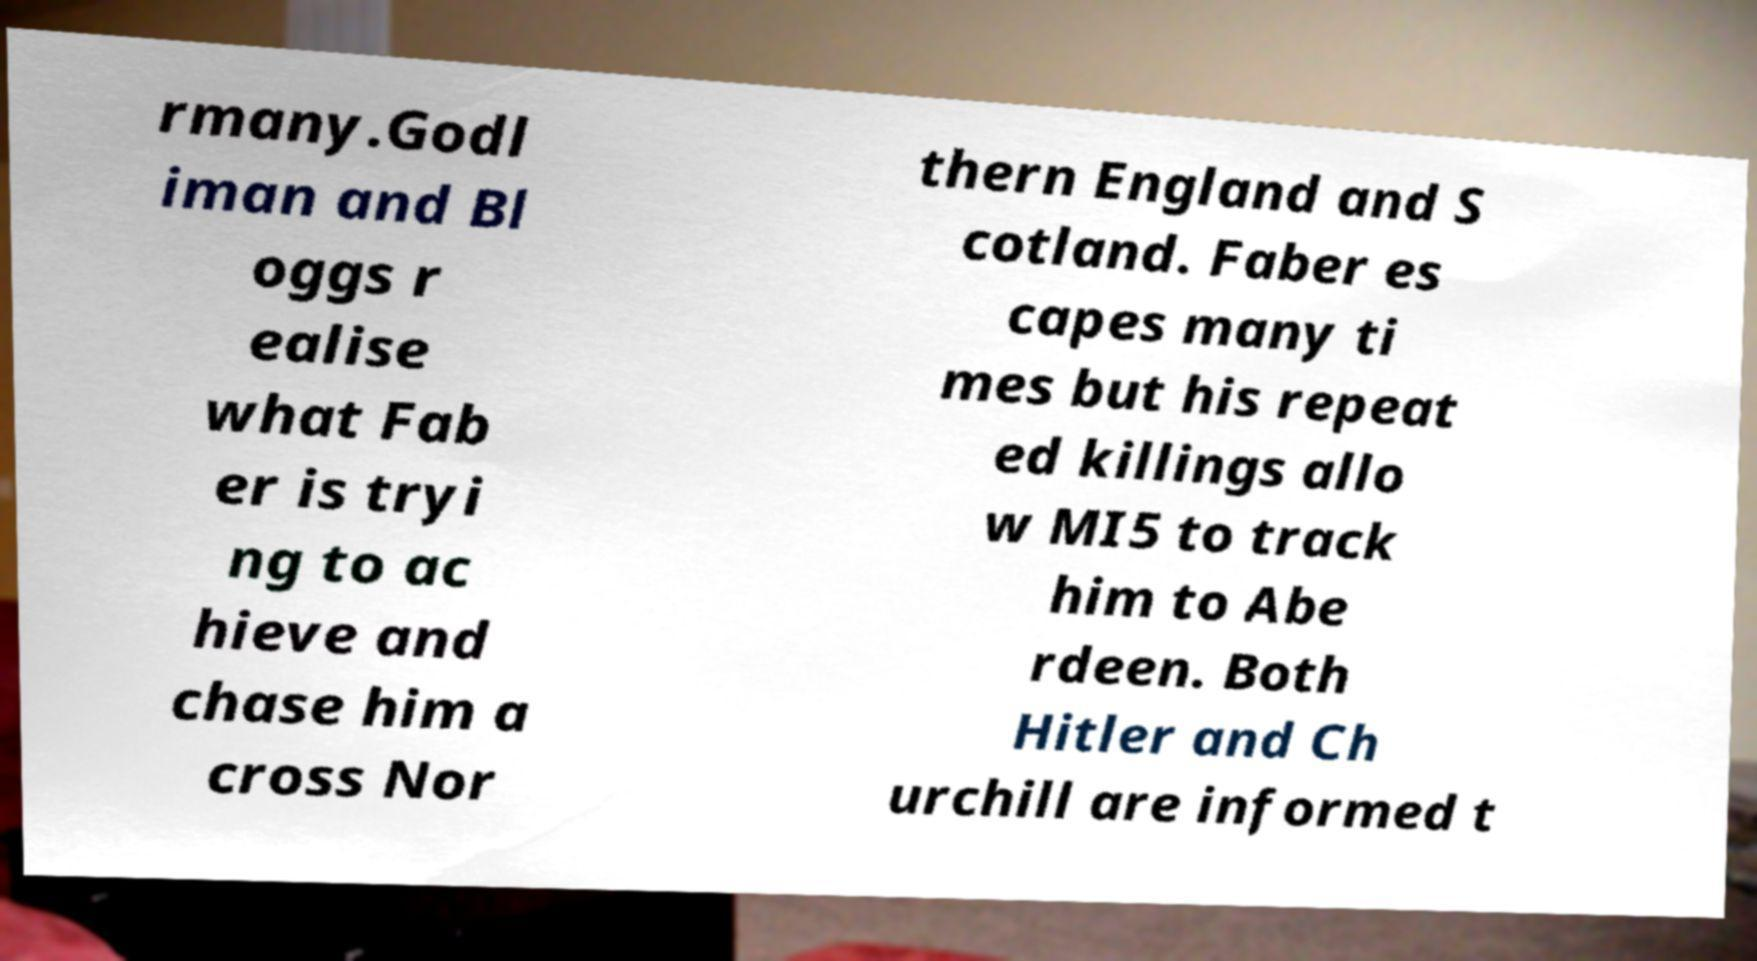There's text embedded in this image that I need extracted. Can you transcribe it verbatim? rmany.Godl iman and Bl oggs r ealise what Fab er is tryi ng to ac hieve and chase him a cross Nor thern England and S cotland. Faber es capes many ti mes but his repeat ed killings allo w MI5 to track him to Abe rdeen. Both Hitler and Ch urchill are informed t 